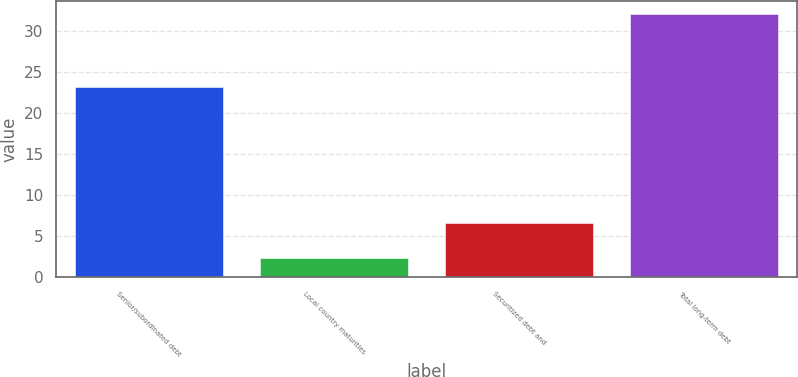Convert chart. <chart><loc_0><loc_0><loc_500><loc_500><bar_chart><fcel>Senior/subordinated debt<fcel>Local country maturities<fcel>Securitized debt and<fcel>Total long-term debt<nl><fcel>23.1<fcel>2.3<fcel>6.6<fcel>32<nl></chart> 